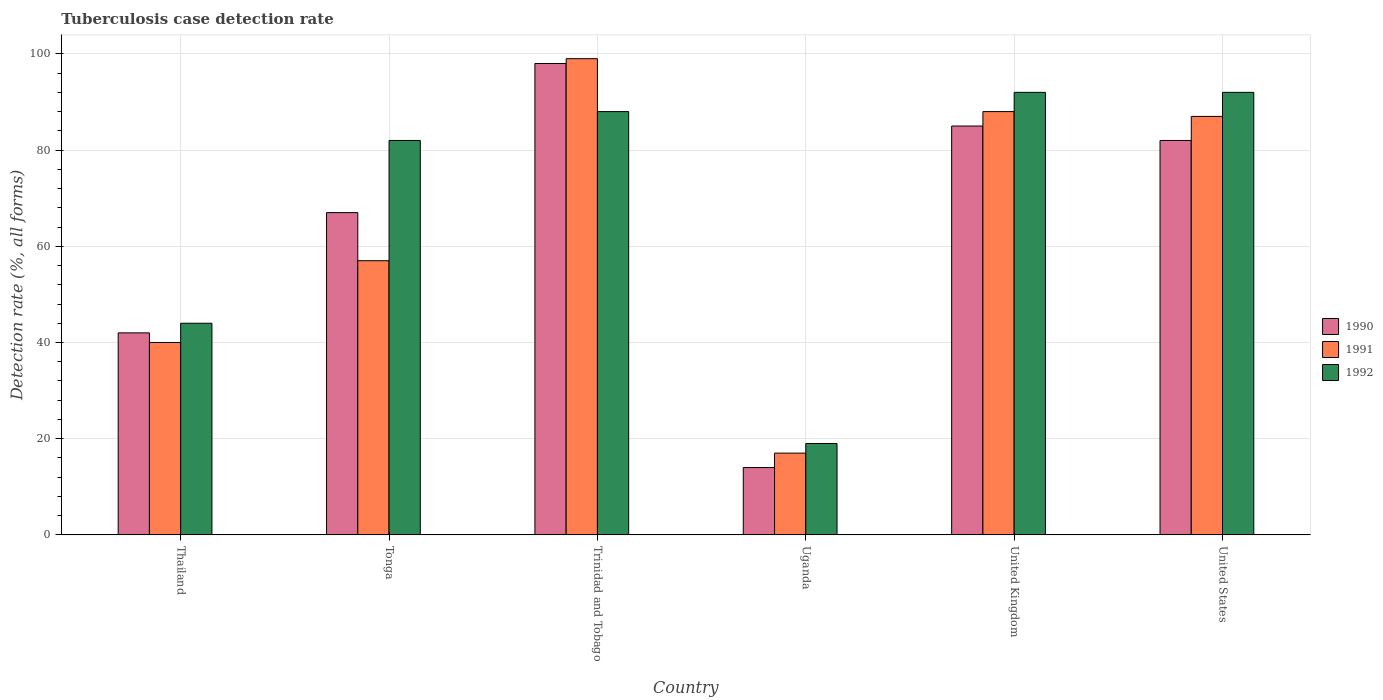How many different coloured bars are there?
Make the answer very short. 3. Are the number of bars per tick equal to the number of legend labels?
Offer a terse response. Yes. How many bars are there on the 6th tick from the right?
Your response must be concise. 3. What is the label of the 2nd group of bars from the left?
Keep it short and to the point. Tonga. In how many cases, is the number of bars for a given country not equal to the number of legend labels?
Give a very brief answer. 0. Across all countries, what is the maximum tuberculosis case detection rate in in 1991?
Offer a terse response. 99. Across all countries, what is the minimum tuberculosis case detection rate in in 1991?
Keep it short and to the point. 17. In which country was the tuberculosis case detection rate in in 1991 maximum?
Ensure brevity in your answer.  Trinidad and Tobago. In which country was the tuberculosis case detection rate in in 1992 minimum?
Your answer should be very brief. Uganda. What is the total tuberculosis case detection rate in in 1990 in the graph?
Your answer should be very brief. 388. What is the difference between the tuberculosis case detection rate in in 1991 in Trinidad and Tobago and that in United Kingdom?
Offer a terse response. 11. What is the difference between the tuberculosis case detection rate in in 1992 in Trinidad and Tobago and the tuberculosis case detection rate in in 1991 in Uganda?
Ensure brevity in your answer.  71. What is the average tuberculosis case detection rate in in 1992 per country?
Offer a terse response. 69.5. What is the difference between the tuberculosis case detection rate in of/in 1992 and tuberculosis case detection rate in of/in 1991 in Trinidad and Tobago?
Make the answer very short. -11. What is the ratio of the tuberculosis case detection rate in in 1990 in Trinidad and Tobago to that in Uganda?
Make the answer very short. 7. In how many countries, is the tuberculosis case detection rate in in 1991 greater than the average tuberculosis case detection rate in in 1991 taken over all countries?
Your answer should be very brief. 3. What does the 2nd bar from the left in Uganda represents?
Your answer should be compact. 1991. What does the 3rd bar from the right in Trinidad and Tobago represents?
Your answer should be very brief. 1990. Is it the case that in every country, the sum of the tuberculosis case detection rate in in 1990 and tuberculosis case detection rate in in 1991 is greater than the tuberculosis case detection rate in in 1992?
Make the answer very short. Yes. Are all the bars in the graph horizontal?
Provide a succinct answer. No. Does the graph contain any zero values?
Provide a succinct answer. No. Does the graph contain grids?
Provide a short and direct response. Yes. How many legend labels are there?
Your response must be concise. 3. How are the legend labels stacked?
Your answer should be very brief. Vertical. What is the title of the graph?
Provide a succinct answer. Tuberculosis case detection rate. What is the label or title of the X-axis?
Keep it short and to the point. Country. What is the label or title of the Y-axis?
Ensure brevity in your answer.  Detection rate (%, all forms). What is the Detection rate (%, all forms) in 1990 in Thailand?
Provide a short and direct response. 42. What is the Detection rate (%, all forms) in 1990 in Tonga?
Make the answer very short. 67. What is the Detection rate (%, all forms) of 1991 in Tonga?
Keep it short and to the point. 57. What is the Detection rate (%, all forms) of 1992 in Tonga?
Your answer should be very brief. 82. What is the Detection rate (%, all forms) in 1990 in Trinidad and Tobago?
Provide a succinct answer. 98. What is the Detection rate (%, all forms) in 1990 in Uganda?
Give a very brief answer. 14. What is the Detection rate (%, all forms) of 1992 in Uganda?
Offer a very short reply. 19. What is the Detection rate (%, all forms) of 1990 in United Kingdom?
Provide a succinct answer. 85. What is the Detection rate (%, all forms) in 1991 in United Kingdom?
Your answer should be very brief. 88. What is the Detection rate (%, all forms) of 1992 in United Kingdom?
Make the answer very short. 92. What is the Detection rate (%, all forms) of 1991 in United States?
Offer a terse response. 87. What is the Detection rate (%, all forms) in 1992 in United States?
Your response must be concise. 92. Across all countries, what is the maximum Detection rate (%, all forms) of 1990?
Offer a very short reply. 98. Across all countries, what is the maximum Detection rate (%, all forms) of 1991?
Ensure brevity in your answer.  99. Across all countries, what is the maximum Detection rate (%, all forms) of 1992?
Provide a short and direct response. 92. Across all countries, what is the minimum Detection rate (%, all forms) of 1990?
Provide a succinct answer. 14. Across all countries, what is the minimum Detection rate (%, all forms) in 1991?
Offer a terse response. 17. What is the total Detection rate (%, all forms) of 1990 in the graph?
Make the answer very short. 388. What is the total Detection rate (%, all forms) of 1991 in the graph?
Offer a terse response. 388. What is the total Detection rate (%, all forms) of 1992 in the graph?
Keep it short and to the point. 417. What is the difference between the Detection rate (%, all forms) in 1991 in Thailand and that in Tonga?
Your response must be concise. -17. What is the difference between the Detection rate (%, all forms) of 1992 in Thailand and that in Tonga?
Make the answer very short. -38. What is the difference between the Detection rate (%, all forms) in 1990 in Thailand and that in Trinidad and Tobago?
Give a very brief answer. -56. What is the difference between the Detection rate (%, all forms) in 1991 in Thailand and that in Trinidad and Tobago?
Your response must be concise. -59. What is the difference between the Detection rate (%, all forms) of 1992 in Thailand and that in Trinidad and Tobago?
Provide a short and direct response. -44. What is the difference between the Detection rate (%, all forms) of 1990 in Thailand and that in Uganda?
Give a very brief answer. 28. What is the difference between the Detection rate (%, all forms) in 1991 in Thailand and that in Uganda?
Your answer should be very brief. 23. What is the difference between the Detection rate (%, all forms) in 1990 in Thailand and that in United Kingdom?
Provide a short and direct response. -43. What is the difference between the Detection rate (%, all forms) in 1991 in Thailand and that in United Kingdom?
Keep it short and to the point. -48. What is the difference between the Detection rate (%, all forms) of 1992 in Thailand and that in United Kingdom?
Provide a succinct answer. -48. What is the difference between the Detection rate (%, all forms) in 1990 in Thailand and that in United States?
Offer a terse response. -40. What is the difference between the Detection rate (%, all forms) in 1991 in Thailand and that in United States?
Keep it short and to the point. -47. What is the difference between the Detection rate (%, all forms) in 1992 in Thailand and that in United States?
Offer a terse response. -48. What is the difference between the Detection rate (%, all forms) of 1990 in Tonga and that in Trinidad and Tobago?
Provide a short and direct response. -31. What is the difference between the Detection rate (%, all forms) in 1991 in Tonga and that in Trinidad and Tobago?
Keep it short and to the point. -42. What is the difference between the Detection rate (%, all forms) in 1990 in Tonga and that in Uganda?
Make the answer very short. 53. What is the difference between the Detection rate (%, all forms) of 1991 in Tonga and that in Uganda?
Your response must be concise. 40. What is the difference between the Detection rate (%, all forms) of 1992 in Tonga and that in Uganda?
Your response must be concise. 63. What is the difference between the Detection rate (%, all forms) of 1991 in Tonga and that in United Kingdom?
Provide a short and direct response. -31. What is the difference between the Detection rate (%, all forms) in 1991 in Tonga and that in United States?
Offer a very short reply. -30. What is the difference between the Detection rate (%, all forms) of 1990 in Trinidad and Tobago and that in Uganda?
Provide a succinct answer. 84. What is the difference between the Detection rate (%, all forms) in 1991 in Trinidad and Tobago and that in Uganda?
Give a very brief answer. 82. What is the difference between the Detection rate (%, all forms) of 1992 in Trinidad and Tobago and that in Uganda?
Provide a succinct answer. 69. What is the difference between the Detection rate (%, all forms) of 1991 in Trinidad and Tobago and that in United Kingdom?
Ensure brevity in your answer.  11. What is the difference between the Detection rate (%, all forms) in 1990 in Trinidad and Tobago and that in United States?
Ensure brevity in your answer.  16. What is the difference between the Detection rate (%, all forms) in 1991 in Trinidad and Tobago and that in United States?
Ensure brevity in your answer.  12. What is the difference between the Detection rate (%, all forms) in 1990 in Uganda and that in United Kingdom?
Provide a short and direct response. -71. What is the difference between the Detection rate (%, all forms) of 1991 in Uganda and that in United Kingdom?
Ensure brevity in your answer.  -71. What is the difference between the Detection rate (%, all forms) in 1992 in Uganda and that in United Kingdom?
Provide a short and direct response. -73. What is the difference between the Detection rate (%, all forms) in 1990 in Uganda and that in United States?
Provide a succinct answer. -68. What is the difference between the Detection rate (%, all forms) in 1991 in Uganda and that in United States?
Make the answer very short. -70. What is the difference between the Detection rate (%, all forms) of 1992 in Uganda and that in United States?
Give a very brief answer. -73. What is the difference between the Detection rate (%, all forms) in 1990 in United Kingdom and that in United States?
Give a very brief answer. 3. What is the difference between the Detection rate (%, all forms) in 1991 in United Kingdom and that in United States?
Give a very brief answer. 1. What is the difference between the Detection rate (%, all forms) in 1992 in United Kingdom and that in United States?
Give a very brief answer. 0. What is the difference between the Detection rate (%, all forms) of 1991 in Thailand and the Detection rate (%, all forms) of 1992 in Tonga?
Offer a very short reply. -42. What is the difference between the Detection rate (%, all forms) in 1990 in Thailand and the Detection rate (%, all forms) in 1991 in Trinidad and Tobago?
Your response must be concise. -57. What is the difference between the Detection rate (%, all forms) of 1990 in Thailand and the Detection rate (%, all forms) of 1992 in Trinidad and Tobago?
Offer a terse response. -46. What is the difference between the Detection rate (%, all forms) in 1991 in Thailand and the Detection rate (%, all forms) in 1992 in Trinidad and Tobago?
Make the answer very short. -48. What is the difference between the Detection rate (%, all forms) of 1990 in Thailand and the Detection rate (%, all forms) of 1991 in Uganda?
Provide a succinct answer. 25. What is the difference between the Detection rate (%, all forms) in 1991 in Thailand and the Detection rate (%, all forms) in 1992 in Uganda?
Ensure brevity in your answer.  21. What is the difference between the Detection rate (%, all forms) of 1990 in Thailand and the Detection rate (%, all forms) of 1991 in United Kingdom?
Keep it short and to the point. -46. What is the difference between the Detection rate (%, all forms) in 1990 in Thailand and the Detection rate (%, all forms) in 1992 in United Kingdom?
Provide a short and direct response. -50. What is the difference between the Detection rate (%, all forms) of 1991 in Thailand and the Detection rate (%, all forms) of 1992 in United Kingdom?
Offer a very short reply. -52. What is the difference between the Detection rate (%, all forms) of 1990 in Thailand and the Detection rate (%, all forms) of 1991 in United States?
Keep it short and to the point. -45. What is the difference between the Detection rate (%, all forms) in 1990 in Thailand and the Detection rate (%, all forms) in 1992 in United States?
Offer a very short reply. -50. What is the difference between the Detection rate (%, all forms) of 1991 in Thailand and the Detection rate (%, all forms) of 1992 in United States?
Offer a terse response. -52. What is the difference between the Detection rate (%, all forms) of 1990 in Tonga and the Detection rate (%, all forms) of 1991 in Trinidad and Tobago?
Offer a very short reply. -32. What is the difference between the Detection rate (%, all forms) in 1991 in Tonga and the Detection rate (%, all forms) in 1992 in Trinidad and Tobago?
Your answer should be very brief. -31. What is the difference between the Detection rate (%, all forms) in 1990 in Tonga and the Detection rate (%, all forms) in 1991 in Uganda?
Ensure brevity in your answer.  50. What is the difference between the Detection rate (%, all forms) in 1990 in Tonga and the Detection rate (%, all forms) in 1992 in Uganda?
Provide a succinct answer. 48. What is the difference between the Detection rate (%, all forms) of 1990 in Tonga and the Detection rate (%, all forms) of 1991 in United Kingdom?
Your answer should be very brief. -21. What is the difference between the Detection rate (%, all forms) in 1991 in Tonga and the Detection rate (%, all forms) in 1992 in United Kingdom?
Keep it short and to the point. -35. What is the difference between the Detection rate (%, all forms) of 1991 in Tonga and the Detection rate (%, all forms) of 1992 in United States?
Ensure brevity in your answer.  -35. What is the difference between the Detection rate (%, all forms) of 1990 in Trinidad and Tobago and the Detection rate (%, all forms) of 1991 in Uganda?
Your answer should be very brief. 81. What is the difference between the Detection rate (%, all forms) of 1990 in Trinidad and Tobago and the Detection rate (%, all forms) of 1992 in Uganda?
Your answer should be very brief. 79. What is the difference between the Detection rate (%, all forms) in 1990 in Trinidad and Tobago and the Detection rate (%, all forms) in 1991 in United Kingdom?
Provide a short and direct response. 10. What is the difference between the Detection rate (%, all forms) of 1990 in Trinidad and Tobago and the Detection rate (%, all forms) of 1992 in United Kingdom?
Offer a terse response. 6. What is the difference between the Detection rate (%, all forms) of 1991 in Trinidad and Tobago and the Detection rate (%, all forms) of 1992 in United Kingdom?
Give a very brief answer. 7. What is the difference between the Detection rate (%, all forms) in 1990 in Trinidad and Tobago and the Detection rate (%, all forms) in 1991 in United States?
Your answer should be very brief. 11. What is the difference between the Detection rate (%, all forms) of 1990 in Trinidad and Tobago and the Detection rate (%, all forms) of 1992 in United States?
Provide a short and direct response. 6. What is the difference between the Detection rate (%, all forms) of 1990 in Uganda and the Detection rate (%, all forms) of 1991 in United Kingdom?
Keep it short and to the point. -74. What is the difference between the Detection rate (%, all forms) in 1990 in Uganda and the Detection rate (%, all forms) in 1992 in United Kingdom?
Keep it short and to the point. -78. What is the difference between the Detection rate (%, all forms) of 1991 in Uganda and the Detection rate (%, all forms) of 1992 in United Kingdom?
Offer a very short reply. -75. What is the difference between the Detection rate (%, all forms) in 1990 in Uganda and the Detection rate (%, all forms) in 1991 in United States?
Ensure brevity in your answer.  -73. What is the difference between the Detection rate (%, all forms) of 1990 in Uganda and the Detection rate (%, all forms) of 1992 in United States?
Your answer should be compact. -78. What is the difference between the Detection rate (%, all forms) in 1991 in Uganda and the Detection rate (%, all forms) in 1992 in United States?
Provide a short and direct response. -75. What is the difference between the Detection rate (%, all forms) of 1991 in United Kingdom and the Detection rate (%, all forms) of 1992 in United States?
Your answer should be very brief. -4. What is the average Detection rate (%, all forms) in 1990 per country?
Provide a short and direct response. 64.67. What is the average Detection rate (%, all forms) in 1991 per country?
Provide a short and direct response. 64.67. What is the average Detection rate (%, all forms) of 1992 per country?
Your answer should be compact. 69.5. What is the difference between the Detection rate (%, all forms) of 1990 and Detection rate (%, all forms) of 1991 in Thailand?
Make the answer very short. 2. What is the difference between the Detection rate (%, all forms) of 1991 and Detection rate (%, all forms) of 1992 in Thailand?
Provide a succinct answer. -4. What is the difference between the Detection rate (%, all forms) of 1990 and Detection rate (%, all forms) of 1991 in Tonga?
Keep it short and to the point. 10. What is the difference between the Detection rate (%, all forms) of 1990 and Detection rate (%, all forms) of 1992 in Tonga?
Ensure brevity in your answer.  -15. What is the difference between the Detection rate (%, all forms) in 1990 and Detection rate (%, all forms) in 1992 in Trinidad and Tobago?
Your answer should be compact. 10. What is the difference between the Detection rate (%, all forms) of 1991 and Detection rate (%, all forms) of 1992 in Trinidad and Tobago?
Keep it short and to the point. 11. What is the difference between the Detection rate (%, all forms) in 1990 and Detection rate (%, all forms) in 1992 in Uganda?
Make the answer very short. -5. What is the difference between the Detection rate (%, all forms) of 1991 and Detection rate (%, all forms) of 1992 in Uganda?
Your answer should be compact. -2. What is the difference between the Detection rate (%, all forms) in 1990 and Detection rate (%, all forms) in 1992 in United Kingdom?
Your answer should be very brief. -7. What is the difference between the Detection rate (%, all forms) of 1990 and Detection rate (%, all forms) of 1992 in United States?
Your answer should be very brief. -10. What is the difference between the Detection rate (%, all forms) in 1991 and Detection rate (%, all forms) in 1992 in United States?
Offer a very short reply. -5. What is the ratio of the Detection rate (%, all forms) of 1990 in Thailand to that in Tonga?
Provide a short and direct response. 0.63. What is the ratio of the Detection rate (%, all forms) in 1991 in Thailand to that in Tonga?
Your answer should be very brief. 0.7. What is the ratio of the Detection rate (%, all forms) in 1992 in Thailand to that in Tonga?
Your answer should be very brief. 0.54. What is the ratio of the Detection rate (%, all forms) in 1990 in Thailand to that in Trinidad and Tobago?
Your answer should be very brief. 0.43. What is the ratio of the Detection rate (%, all forms) in 1991 in Thailand to that in Trinidad and Tobago?
Make the answer very short. 0.4. What is the ratio of the Detection rate (%, all forms) in 1991 in Thailand to that in Uganda?
Offer a terse response. 2.35. What is the ratio of the Detection rate (%, all forms) of 1992 in Thailand to that in Uganda?
Your answer should be very brief. 2.32. What is the ratio of the Detection rate (%, all forms) in 1990 in Thailand to that in United Kingdom?
Offer a terse response. 0.49. What is the ratio of the Detection rate (%, all forms) in 1991 in Thailand to that in United Kingdom?
Your response must be concise. 0.45. What is the ratio of the Detection rate (%, all forms) in 1992 in Thailand to that in United Kingdom?
Ensure brevity in your answer.  0.48. What is the ratio of the Detection rate (%, all forms) of 1990 in Thailand to that in United States?
Provide a succinct answer. 0.51. What is the ratio of the Detection rate (%, all forms) of 1991 in Thailand to that in United States?
Provide a short and direct response. 0.46. What is the ratio of the Detection rate (%, all forms) in 1992 in Thailand to that in United States?
Your answer should be very brief. 0.48. What is the ratio of the Detection rate (%, all forms) of 1990 in Tonga to that in Trinidad and Tobago?
Offer a terse response. 0.68. What is the ratio of the Detection rate (%, all forms) of 1991 in Tonga to that in Trinidad and Tobago?
Make the answer very short. 0.58. What is the ratio of the Detection rate (%, all forms) of 1992 in Tonga to that in Trinidad and Tobago?
Your answer should be very brief. 0.93. What is the ratio of the Detection rate (%, all forms) in 1990 in Tonga to that in Uganda?
Ensure brevity in your answer.  4.79. What is the ratio of the Detection rate (%, all forms) of 1991 in Tonga to that in Uganda?
Your answer should be very brief. 3.35. What is the ratio of the Detection rate (%, all forms) of 1992 in Tonga to that in Uganda?
Offer a very short reply. 4.32. What is the ratio of the Detection rate (%, all forms) in 1990 in Tonga to that in United Kingdom?
Offer a very short reply. 0.79. What is the ratio of the Detection rate (%, all forms) of 1991 in Tonga to that in United Kingdom?
Offer a very short reply. 0.65. What is the ratio of the Detection rate (%, all forms) of 1992 in Tonga to that in United Kingdom?
Keep it short and to the point. 0.89. What is the ratio of the Detection rate (%, all forms) in 1990 in Tonga to that in United States?
Offer a very short reply. 0.82. What is the ratio of the Detection rate (%, all forms) in 1991 in Tonga to that in United States?
Keep it short and to the point. 0.66. What is the ratio of the Detection rate (%, all forms) of 1992 in Tonga to that in United States?
Your answer should be very brief. 0.89. What is the ratio of the Detection rate (%, all forms) in 1990 in Trinidad and Tobago to that in Uganda?
Your answer should be compact. 7. What is the ratio of the Detection rate (%, all forms) in 1991 in Trinidad and Tobago to that in Uganda?
Give a very brief answer. 5.82. What is the ratio of the Detection rate (%, all forms) in 1992 in Trinidad and Tobago to that in Uganda?
Your answer should be very brief. 4.63. What is the ratio of the Detection rate (%, all forms) of 1990 in Trinidad and Tobago to that in United Kingdom?
Provide a succinct answer. 1.15. What is the ratio of the Detection rate (%, all forms) in 1991 in Trinidad and Tobago to that in United Kingdom?
Your answer should be very brief. 1.12. What is the ratio of the Detection rate (%, all forms) in 1992 in Trinidad and Tobago to that in United Kingdom?
Provide a succinct answer. 0.96. What is the ratio of the Detection rate (%, all forms) of 1990 in Trinidad and Tobago to that in United States?
Make the answer very short. 1.2. What is the ratio of the Detection rate (%, all forms) in 1991 in Trinidad and Tobago to that in United States?
Your answer should be compact. 1.14. What is the ratio of the Detection rate (%, all forms) of 1992 in Trinidad and Tobago to that in United States?
Give a very brief answer. 0.96. What is the ratio of the Detection rate (%, all forms) of 1990 in Uganda to that in United Kingdom?
Provide a short and direct response. 0.16. What is the ratio of the Detection rate (%, all forms) of 1991 in Uganda to that in United Kingdom?
Offer a terse response. 0.19. What is the ratio of the Detection rate (%, all forms) in 1992 in Uganda to that in United Kingdom?
Your response must be concise. 0.21. What is the ratio of the Detection rate (%, all forms) in 1990 in Uganda to that in United States?
Provide a short and direct response. 0.17. What is the ratio of the Detection rate (%, all forms) in 1991 in Uganda to that in United States?
Offer a very short reply. 0.2. What is the ratio of the Detection rate (%, all forms) in 1992 in Uganda to that in United States?
Your answer should be compact. 0.21. What is the ratio of the Detection rate (%, all forms) in 1990 in United Kingdom to that in United States?
Ensure brevity in your answer.  1.04. What is the ratio of the Detection rate (%, all forms) of 1991 in United Kingdom to that in United States?
Give a very brief answer. 1.01. What is the difference between the highest and the second highest Detection rate (%, all forms) of 1990?
Give a very brief answer. 13. What is the difference between the highest and the second highest Detection rate (%, all forms) of 1991?
Offer a very short reply. 11. What is the difference between the highest and the lowest Detection rate (%, all forms) in 1990?
Give a very brief answer. 84. 